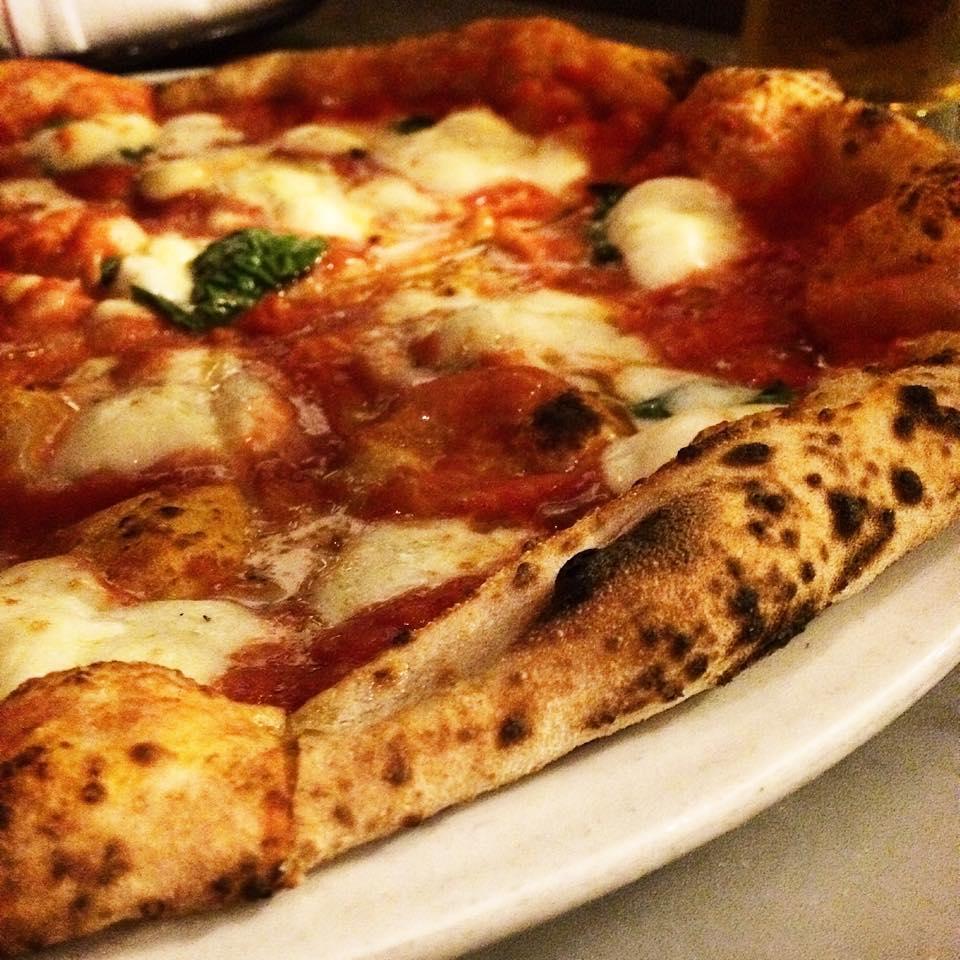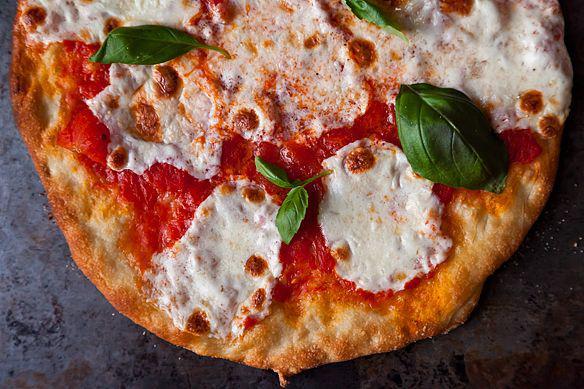The first image is the image on the left, the second image is the image on the right. Considering the images on both sides, is "The right image shows one slice of a round pizza separated by a small distance from the rest." valid? Answer yes or no. No. The first image is the image on the left, the second image is the image on the right. For the images displayed, is the sentence "there is a pizza with rounds of mozzarella melted and green bits of basil" factually correct? Answer yes or no. Yes. 